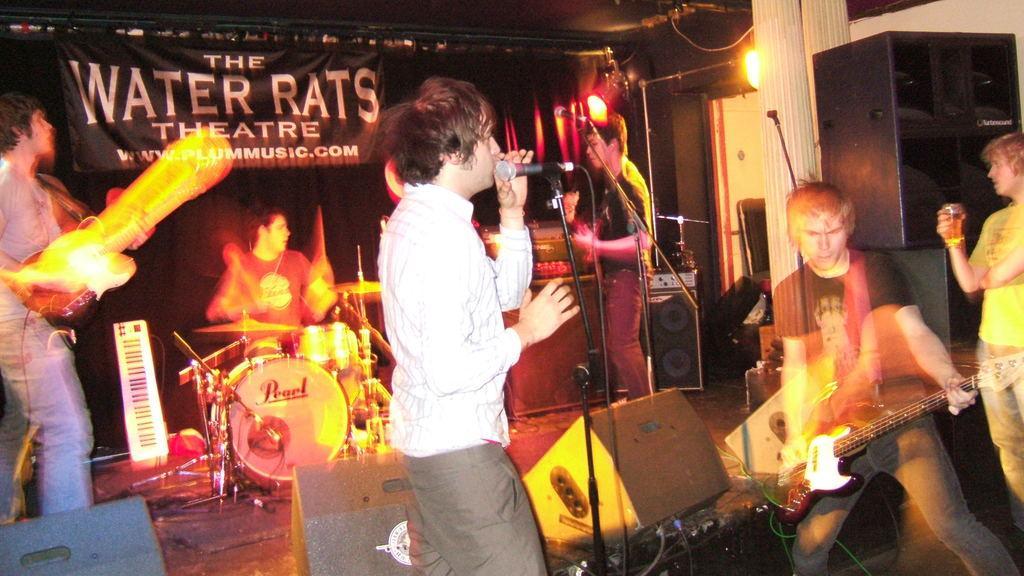In one or two sentences, can you explain what this image depicts? In this image I see 5 men, in which 3 of them are holding the musical instruments, another one is holding a glass and this guy is holding the mic. In the background I see the banner, lights and the speakers. 